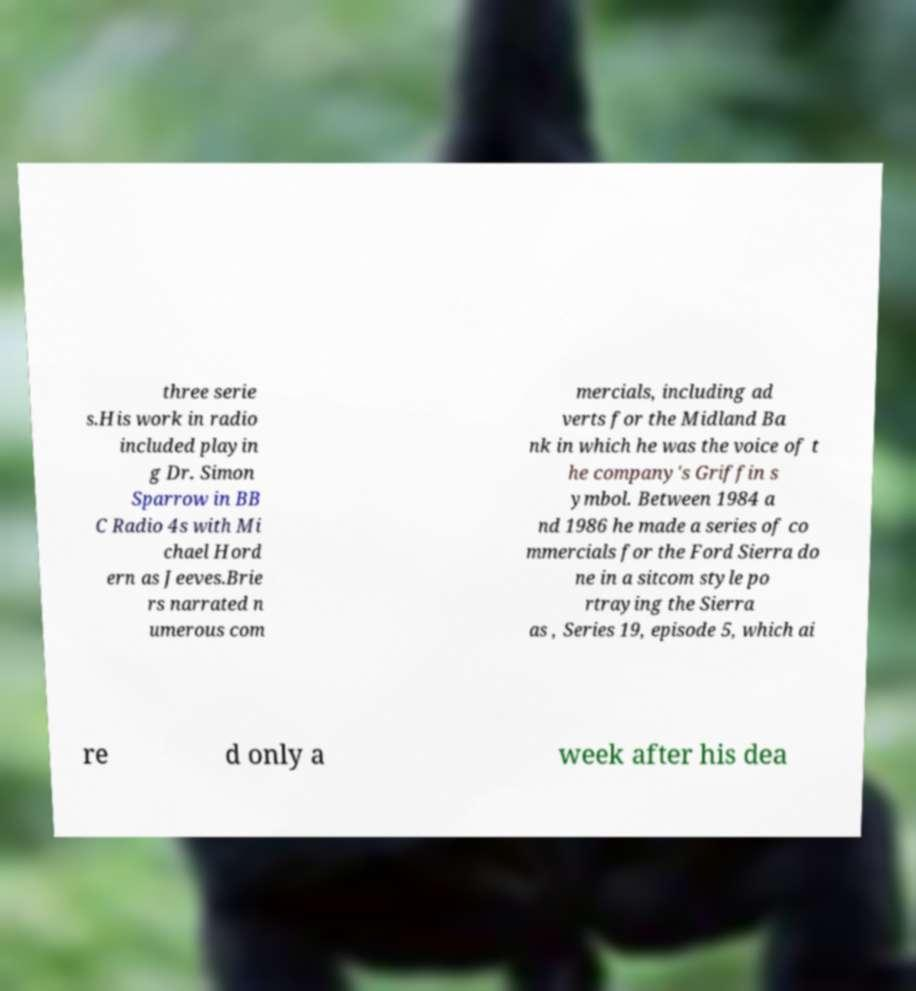There's text embedded in this image that I need extracted. Can you transcribe it verbatim? three serie s.His work in radio included playin g Dr. Simon Sparrow in BB C Radio 4s with Mi chael Hord ern as Jeeves.Brie rs narrated n umerous com mercials, including ad verts for the Midland Ba nk in which he was the voice of t he company's Griffin s ymbol. Between 1984 a nd 1986 he made a series of co mmercials for the Ford Sierra do ne in a sitcom style po rtraying the Sierra as , Series 19, episode 5, which ai re d only a week after his dea 